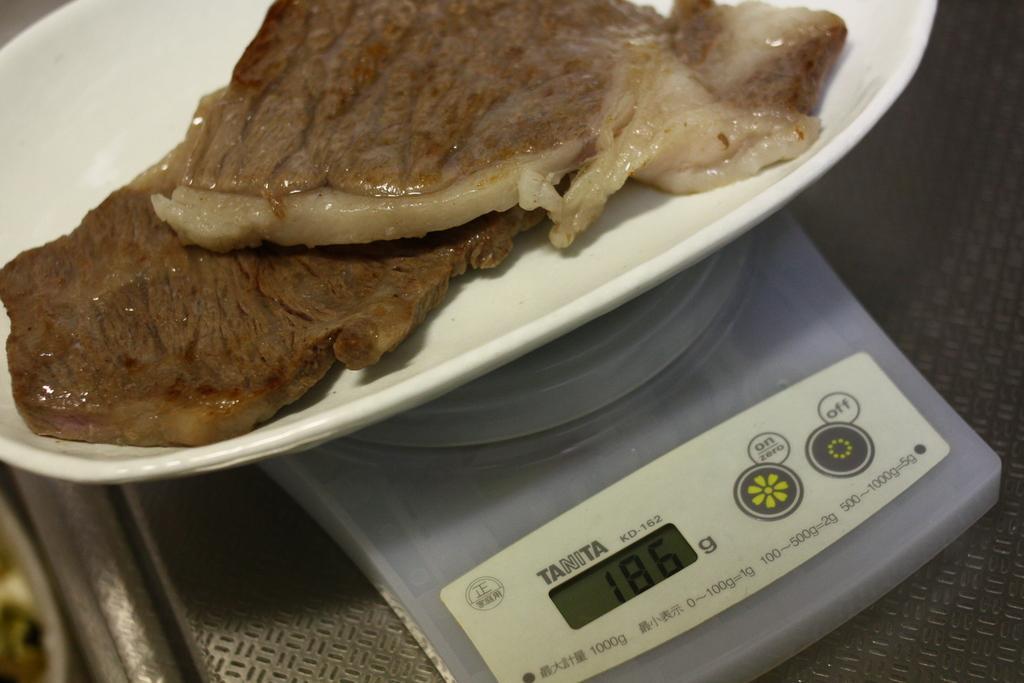Can you describe this image briefly? In this image, we can see a weighing machine, we can see some non veg on the pan. 